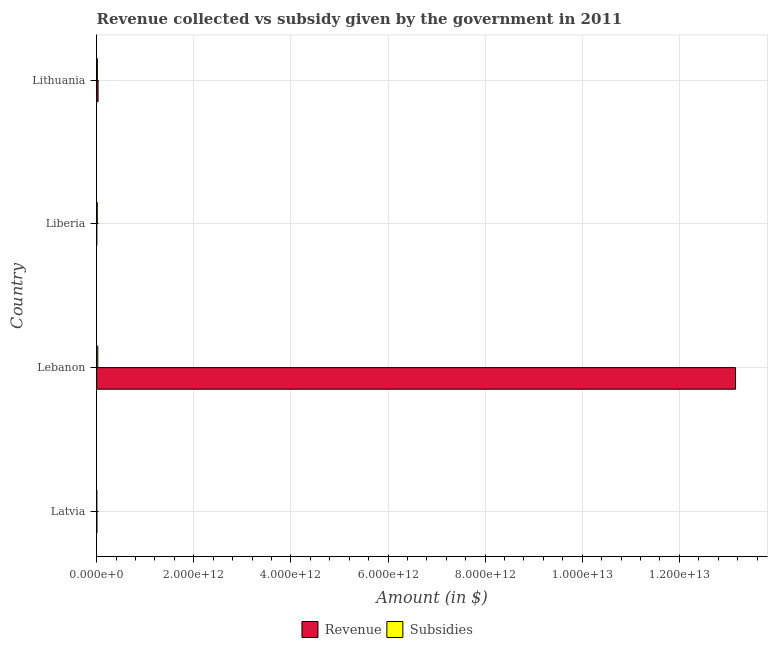How many different coloured bars are there?
Provide a short and direct response. 2. How many groups of bars are there?
Your answer should be very brief. 4. How many bars are there on the 1st tick from the bottom?
Provide a short and direct response. 2. What is the label of the 4th group of bars from the top?
Your answer should be compact. Latvia. In how many cases, is the number of bars for a given country not equal to the number of legend labels?
Offer a terse response. 0. What is the amount of subsidies given in Lebanon?
Offer a very short reply. 2.24e+1. Across all countries, what is the maximum amount of subsidies given?
Ensure brevity in your answer.  2.24e+1. Across all countries, what is the minimum amount of revenue collected?
Your answer should be compact. 4.43e+06. In which country was the amount of revenue collected maximum?
Make the answer very short. Lebanon. In which country was the amount of subsidies given minimum?
Make the answer very short. Latvia. What is the total amount of subsidies given in the graph?
Your response must be concise. 4.63e+1. What is the difference between the amount of revenue collected in Lebanon and that in Lithuania?
Your answer should be very brief. 1.31e+13. What is the difference between the amount of revenue collected in Latvia and the amount of subsidies given in Liberia?
Make the answer very short. -7.62e+09. What is the average amount of revenue collected per country?
Your answer should be very brief. 3.30e+12. What is the difference between the amount of subsidies given and amount of revenue collected in Lithuania?
Ensure brevity in your answer.  -1.52e+1. What is the ratio of the amount of subsidies given in Latvia to that in Liberia?
Your response must be concise. 0. Is the difference between the amount of subsidies given in Lebanon and Liberia greater than the difference between the amount of revenue collected in Lebanon and Liberia?
Provide a short and direct response. No. What is the difference between the highest and the second highest amount of subsidies given?
Ensure brevity in your answer.  9.60e+09. What is the difference between the highest and the lowest amount of subsidies given?
Provide a succinct answer. 2.24e+1. In how many countries, is the amount of revenue collected greater than the average amount of revenue collected taken over all countries?
Offer a terse response. 1. Is the sum of the amount of subsidies given in Latvia and Liberia greater than the maximum amount of revenue collected across all countries?
Your answer should be very brief. No. What does the 1st bar from the top in Lebanon represents?
Offer a terse response. Subsidies. What does the 2nd bar from the bottom in Lebanon represents?
Your answer should be compact. Subsidies. How many bars are there?
Provide a short and direct response. 8. How many countries are there in the graph?
Make the answer very short. 4. What is the difference between two consecutive major ticks on the X-axis?
Give a very brief answer. 2.00e+12. Does the graph contain grids?
Make the answer very short. Yes. Where does the legend appear in the graph?
Your answer should be very brief. Bottom center. What is the title of the graph?
Offer a very short reply. Revenue collected vs subsidy given by the government in 2011. Does "Study and work" appear as one of the legend labels in the graph?
Provide a short and direct response. No. What is the label or title of the X-axis?
Provide a short and direct response. Amount (in $). What is the Amount (in $) in Revenue in Latvia?
Provide a short and direct response. 3.54e+09. What is the Amount (in $) in Subsidies in Latvia?
Provide a short and direct response. 1.13e+06. What is the Amount (in $) of Revenue in Lebanon?
Give a very brief answer. 1.32e+13. What is the Amount (in $) of Subsidies in Lebanon?
Offer a terse response. 2.24e+1. What is the Amount (in $) of Revenue in Liberia?
Offer a very short reply. 4.43e+06. What is the Amount (in $) in Subsidies in Liberia?
Your answer should be compact. 1.12e+1. What is the Amount (in $) in Revenue in Lithuania?
Provide a short and direct response. 2.80e+1. What is the Amount (in $) in Subsidies in Lithuania?
Provide a short and direct response. 1.28e+1. Across all countries, what is the maximum Amount (in $) in Revenue?
Provide a succinct answer. 1.32e+13. Across all countries, what is the maximum Amount (in $) in Subsidies?
Your answer should be compact. 2.24e+1. Across all countries, what is the minimum Amount (in $) of Revenue?
Keep it short and to the point. 4.43e+06. Across all countries, what is the minimum Amount (in $) of Subsidies?
Provide a short and direct response. 1.13e+06. What is the total Amount (in $) of Revenue in the graph?
Your answer should be very brief. 1.32e+13. What is the total Amount (in $) of Subsidies in the graph?
Give a very brief answer. 4.63e+1. What is the difference between the Amount (in $) of Revenue in Latvia and that in Lebanon?
Your answer should be compact. -1.32e+13. What is the difference between the Amount (in $) of Subsidies in Latvia and that in Lebanon?
Offer a terse response. -2.24e+1. What is the difference between the Amount (in $) in Revenue in Latvia and that in Liberia?
Ensure brevity in your answer.  3.54e+09. What is the difference between the Amount (in $) in Subsidies in Latvia and that in Liberia?
Your response must be concise. -1.12e+1. What is the difference between the Amount (in $) of Revenue in Latvia and that in Lithuania?
Make the answer very short. -2.45e+1. What is the difference between the Amount (in $) in Subsidies in Latvia and that in Lithuania?
Make the answer very short. -1.28e+1. What is the difference between the Amount (in $) in Revenue in Lebanon and that in Liberia?
Provide a succinct answer. 1.32e+13. What is the difference between the Amount (in $) of Subsidies in Lebanon and that in Liberia?
Provide a succinct answer. 1.12e+1. What is the difference between the Amount (in $) of Revenue in Lebanon and that in Lithuania?
Provide a succinct answer. 1.31e+13. What is the difference between the Amount (in $) in Subsidies in Lebanon and that in Lithuania?
Your answer should be very brief. 9.60e+09. What is the difference between the Amount (in $) in Revenue in Liberia and that in Lithuania?
Your answer should be compact. -2.80e+1. What is the difference between the Amount (in $) in Subsidies in Liberia and that in Lithuania?
Provide a short and direct response. -1.62e+09. What is the difference between the Amount (in $) of Revenue in Latvia and the Amount (in $) of Subsidies in Lebanon?
Give a very brief answer. -1.88e+1. What is the difference between the Amount (in $) in Revenue in Latvia and the Amount (in $) in Subsidies in Liberia?
Your response must be concise. -7.62e+09. What is the difference between the Amount (in $) of Revenue in Latvia and the Amount (in $) of Subsidies in Lithuania?
Your response must be concise. -9.25e+09. What is the difference between the Amount (in $) of Revenue in Lebanon and the Amount (in $) of Subsidies in Liberia?
Provide a short and direct response. 1.31e+13. What is the difference between the Amount (in $) in Revenue in Lebanon and the Amount (in $) in Subsidies in Lithuania?
Offer a terse response. 1.31e+13. What is the difference between the Amount (in $) in Revenue in Liberia and the Amount (in $) in Subsidies in Lithuania?
Give a very brief answer. -1.28e+1. What is the average Amount (in $) of Revenue per country?
Your answer should be very brief. 3.30e+12. What is the average Amount (in $) in Subsidies per country?
Keep it short and to the point. 1.16e+1. What is the difference between the Amount (in $) of Revenue and Amount (in $) of Subsidies in Latvia?
Your answer should be compact. 3.54e+09. What is the difference between the Amount (in $) in Revenue and Amount (in $) in Subsidies in Lebanon?
Make the answer very short. 1.31e+13. What is the difference between the Amount (in $) of Revenue and Amount (in $) of Subsidies in Liberia?
Ensure brevity in your answer.  -1.12e+1. What is the difference between the Amount (in $) in Revenue and Amount (in $) in Subsidies in Lithuania?
Give a very brief answer. 1.52e+1. What is the ratio of the Amount (in $) of Subsidies in Latvia to that in Lebanon?
Make the answer very short. 0. What is the ratio of the Amount (in $) in Revenue in Latvia to that in Liberia?
Ensure brevity in your answer.  800.15. What is the ratio of the Amount (in $) in Revenue in Latvia to that in Lithuania?
Ensure brevity in your answer.  0.13. What is the ratio of the Amount (in $) of Subsidies in Latvia to that in Lithuania?
Your answer should be very brief. 0. What is the ratio of the Amount (in $) in Revenue in Lebanon to that in Liberia?
Provide a succinct answer. 2.97e+06. What is the ratio of the Amount (in $) of Subsidies in Lebanon to that in Liberia?
Offer a terse response. 2.01. What is the ratio of the Amount (in $) in Revenue in Lebanon to that in Lithuania?
Offer a terse response. 470.03. What is the ratio of the Amount (in $) in Subsidies in Lebanon to that in Lithuania?
Offer a terse response. 1.75. What is the ratio of the Amount (in $) of Revenue in Liberia to that in Lithuania?
Your answer should be compact. 0. What is the ratio of the Amount (in $) of Subsidies in Liberia to that in Lithuania?
Keep it short and to the point. 0.87. What is the difference between the highest and the second highest Amount (in $) in Revenue?
Provide a short and direct response. 1.31e+13. What is the difference between the highest and the second highest Amount (in $) of Subsidies?
Provide a short and direct response. 9.60e+09. What is the difference between the highest and the lowest Amount (in $) of Revenue?
Give a very brief answer. 1.32e+13. What is the difference between the highest and the lowest Amount (in $) in Subsidies?
Offer a terse response. 2.24e+1. 